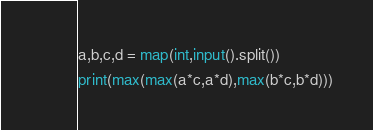<code> <loc_0><loc_0><loc_500><loc_500><_Python_>a,b,c,d = map(int,input().split())
print(max(max(a*c,a*d),max(b*c,b*d)))</code> 